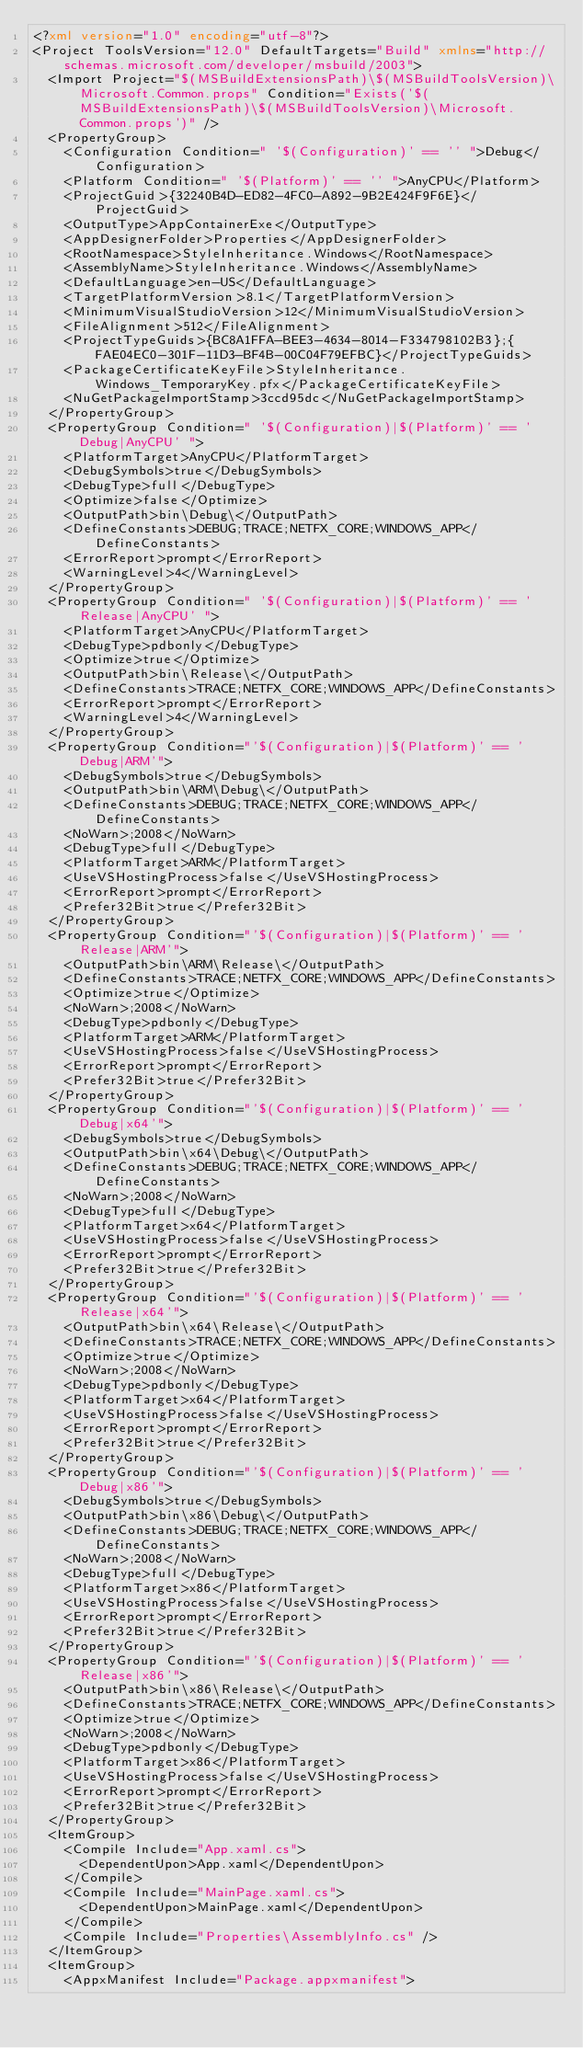Convert code to text. <code><loc_0><loc_0><loc_500><loc_500><_XML_><?xml version="1.0" encoding="utf-8"?>
<Project ToolsVersion="12.0" DefaultTargets="Build" xmlns="http://schemas.microsoft.com/developer/msbuild/2003">
  <Import Project="$(MSBuildExtensionsPath)\$(MSBuildToolsVersion)\Microsoft.Common.props" Condition="Exists('$(MSBuildExtensionsPath)\$(MSBuildToolsVersion)\Microsoft.Common.props')" />
  <PropertyGroup>
    <Configuration Condition=" '$(Configuration)' == '' ">Debug</Configuration>
    <Platform Condition=" '$(Platform)' == '' ">AnyCPU</Platform>
    <ProjectGuid>{32240B4D-ED82-4FC0-A892-9B2E424F9F6E}</ProjectGuid>
    <OutputType>AppContainerExe</OutputType>
    <AppDesignerFolder>Properties</AppDesignerFolder>
    <RootNamespace>StyleInheritance.Windows</RootNamespace>
    <AssemblyName>StyleInheritance.Windows</AssemblyName>
    <DefaultLanguage>en-US</DefaultLanguage>
    <TargetPlatformVersion>8.1</TargetPlatformVersion>
    <MinimumVisualStudioVersion>12</MinimumVisualStudioVersion>
    <FileAlignment>512</FileAlignment>
    <ProjectTypeGuids>{BC8A1FFA-BEE3-4634-8014-F334798102B3};{FAE04EC0-301F-11D3-BF4B-00C04F79EFBC}</ProjectTypeGuids>
    <PackageCertificateKeyFile>StyleInheritance.Windows_TemporaryKey.pfx</PackageCertificateKeyFile>
    <NuGetPackageImportStamp>3ccd95dc</NuGetPackageImportStamp>
  </PropertyGroup>
  <PropertyGroup Condition=" '$(Configuration)|$(Platform)' == 'Debug|AnyCPU' ">
    <PlatformTarget>AnyCPU</PlatformTarget>
    <DebugSymbols>true</DebugSymbols>
    <DebugType>full</DebugType>
    <Optimize>false</Optimize>
    <OutputPath>bin\Debug\</OutputPath>
    <DefineConstants>DEBUG;TRACE;NETFX_CORE;WINDOWS_APP</DefineConstants>
    <ErrorReport>prompt</ErrorReport>
    <WarningLevel>4</WarningLevel>
  </PropertyGroup>
  <PropertyGroup Condition=" '$(Configuration)|$(Platform)' == 'Release|AnyCPU' ">
    <PlatformTarget>AnyCPU</PlatformTarget>
    <DebugType>pdbonly</DebugType>
    <Optimize>true</Optimize>
    <OutputPath>bin\Release\</OutputPath>
    <DefineConstants>TRACE;NETFX_CORE;WINDOWS_APP</DefineConstants>
    <ErrorReport>prompt</ErrorReport>
    <WarningLevel>4</WarningLevel>
  </PropertyGroup>
  <PropertyGroup Condition="'$(Configuration)|$(Platform)' == 'Debug|ARM'">
    <DebugSymbols>true</DebugSymbols>
    <OutputPath>bin\ARM\Debug\</OutputPath>
    <DefineConstants>DEBUG;TRACE;NETFX_CORE;WINDOWS_APP</DefineConstants>
    <NoWarn>;2008</NoWarn>
    <DebugType>full</DebugType>
    <PlatformTarget>ARM</PlatformTarget>
    <UseVSHostingProcess>false</UseVSHostingProcess>
    <ErrorReport>prompt</ErrorReport>
    <Prefer32Bit>true</Prefer32Bit>
  </PropertyGroup>
  <PropertyGroup Condition="'$(Configuration)|$(Platform)' == 'Release|ARM'">
    <OutputPath>bin\ARM\Release\</OutputPath>
    <DefineConstants>TRACE;NETFX_CORE;WINDOWS_APP</DefineConstants>
    <Optimize>true</Optimize>
    <NoWarn>;2008</NoWarn>
    <DebugType>pdbonly</DebugType>
    <PlatformTarget>ARM</PlatformTarget>
    <UseVSHostingProcess>false</UseVSHostingProcess>
    <ErrorReport>prompt</ErrorReport>
    <Prefer32Bit>true</Prefer32Bit>
  </PropertyGroup>
  <PropertyGroup Condition="'$(Configuration)|$(Platform)' == 'Debug|x64'">
    <DebugSymbols>true</DebugSymbols>
    <OutputPath>bin\x64\Debug\</OutputPath>
    <DefineConstants>DEBUG;TRACE;NETFX_CORE;WINDOWS_APP</DefineConstants>
    <NoWarn>;2008</NoWarn>
    <DebugType>full</DebugType>
    <PlatformTarget>x64</PlatformTarget>
    <UseVSHostingProcess>false</UseVSHostingProcess>
    <ErrorReport>prompt</ErrorReport>
    <Prefer32Bit>true</Prefer32Bit>
  </PropertyGroup>
  <PropertyGroup Condition="'$(Configuration)|$(Platform)' == 'Release|x64'">
    <OutputPath>bin\x64\Release\</OutputPath>
    <DefineConstants>TRACE;NETFX_CORE;WINDOWS_APP</DefineConstants>
    <Optimize>true</Optimize>
    <NoWarn>;2008</NoWarn>
    <DebugType>pdbonly</DebugType>
    <PlatformTarget>x64</PlatformTarget>
    <UseVSHostingProcess>false</UseVSHostingProcess>
    <ErrorReport>prompt</ErrorReport>
    <Prefer32Bit>true</Prefer32Bit>
  </PropertyGroup>
  <PropertyGroup Condition="'$(Configuration)|$(Platform)' == 'Debug|x86'">
    <DebugSymbols>true</DebugSymbols>
    <OutputPath>bin\x86\Debug\</OutputPath>
    <DefineConstants>DEBUG;TRACE;NETFX_CORE;WINDOWS_APP</DefineConstants>
    <NoWarn>;2008</NoWarn>
    <DebugType>full</DebugType>
    <PlatformTarget>x86</PlatformTarget>
    <UseVSHostingProcess>false</UseVSHostingProcess>
    <ErrorReport>prompt</ErrorReport>
    <Prefer32Bit>true</Prefer32Bit>
  </PropertyGroup>
  <PropertyGroup Condition="'$(Configuration)|$(Platform)' == 'Release|x86'">
    <OutputPath>bin\x86\Release\</OutputPath>
    <DefineConstants>TRACE;NETFX_CORE;WINDOWS_APP</DefineConstants>
    <Optimize>true</Optimize>
    <NoWarn>;2008</NoWarn>
    <DebugType>pdbonly</DebugType>
    <PlatformTarget>x86</PlatformTarget>
    <UseVSHostingProcess>false</UseVSHostingProcess>
    <ErrorReport>prompt</ErrorReport>
    <Prefer32Bit>true</Prefer32Bit>
  </PropertyGroup>
  <ItemGroup>
    <Compile Include="App.xaml.cs">
      <DependentUpon>App.xaml</DependentUpon>
    </Compile>
    <Compile Include="MainPage.xaml.cs">
      <DependentUpon>MainPage.xaml</DependentUpon>
    </Compile>
    <Compile Include="Properties\AssemblyInfo.cs" />
  </ItemGroup>
  <ItemGroup>
    <AppxManifest Include="Package.appxmanifest"></code> 